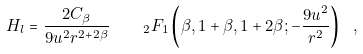<formula> <loc_0><loc_0><loc_500><loc_500>H _ { l } = \frac { 2 C _ { \beta } } { 9 u ^ { 2 } r ^ { 2 + 2 \beta } } \quad _ { 2 } F _ { 1 } \left ( \beta , 1 + \beta , 1 + 2 \beta ; - \frac { 9 u ^ { 2 } } { r ^ { 2 } } \right ) \ ,</formula> 